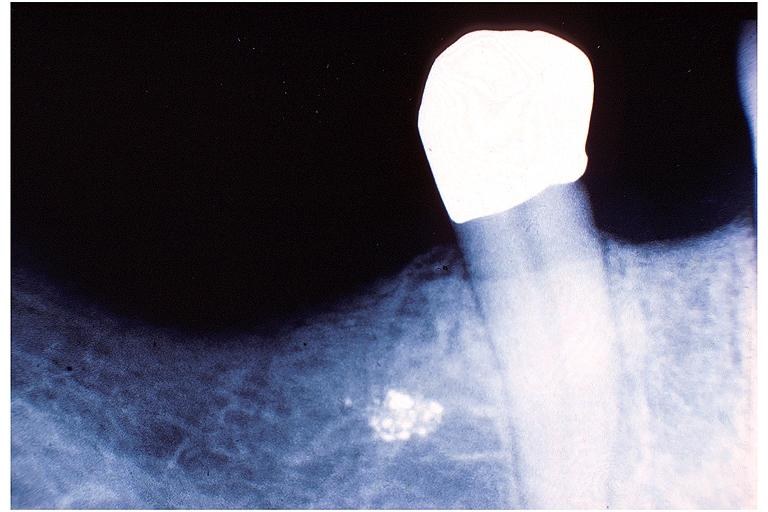s oral present?
Answer the question using a single word or phrase. Yes 